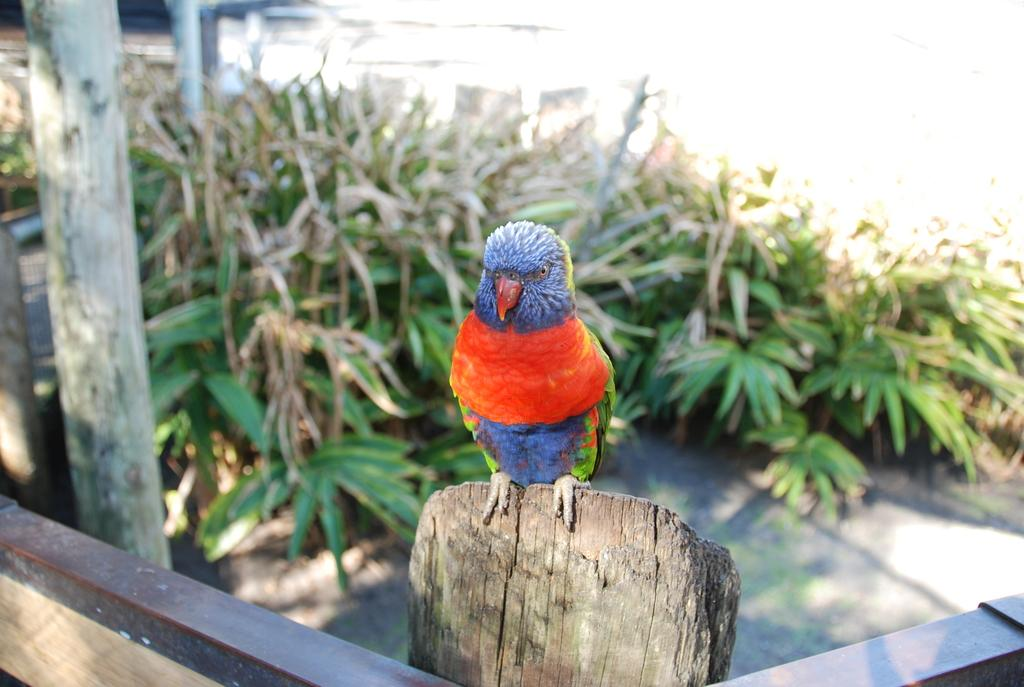What type of animal is in the image? There is a bird in the image. What colors can be seen on the bird? The bird has red, blue, and green colors. What is the bird sitting on? The bird is on a wooden object. What can be seen to the left of the image? There is a pole and plants to the left of the image. What color is the background of the image? The background of the image is white. What month is the bird learning to fly in the image? The image does not provide information about the month or the bird learning to fly. 